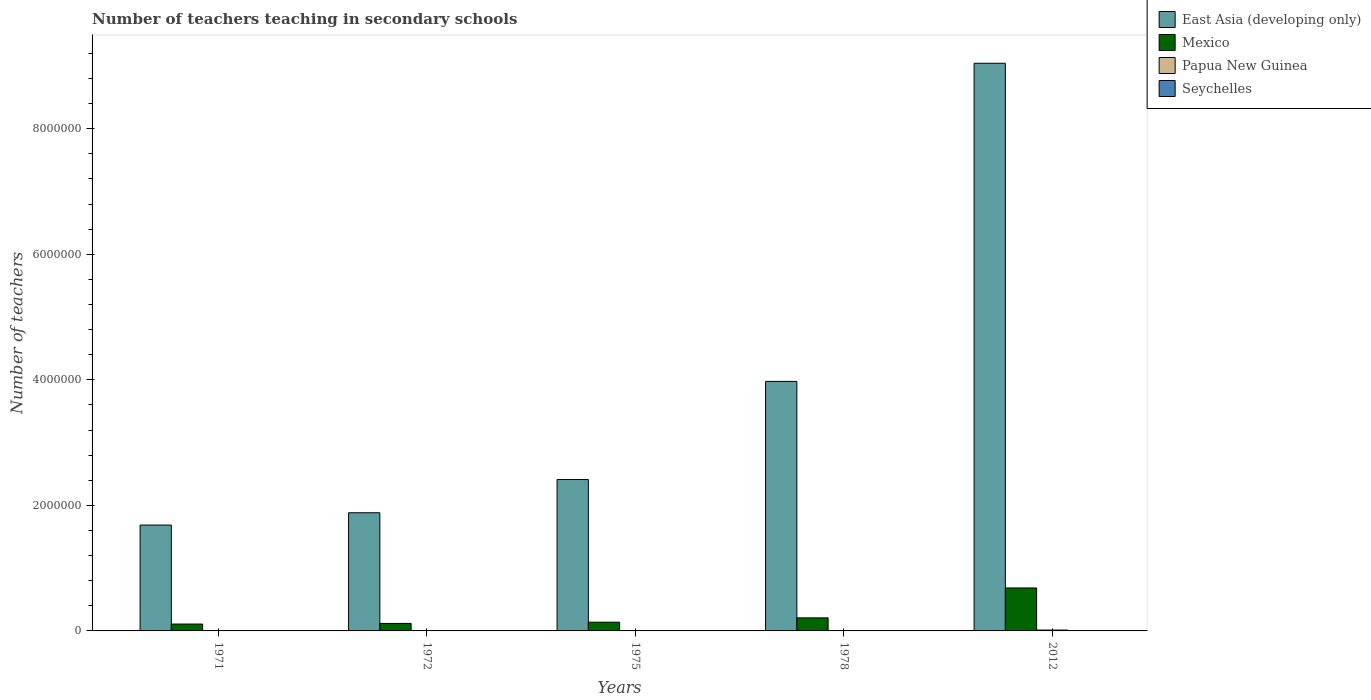How many different coloured bars are there?
Ensure brevity in your answer.  4. Are the number of bars on each tick of the X-axis equal?
Give a very brief answer. Yes. What is the label of the 1st group of bars from the left?
Offer a terse response. 1971. What is the number of teachers teaching in secondary schools in Mexico in 1975?
Your response must be concise. 1.39e+05. Across all years, what is the maximum number of teachers teaching in secondary schools in East Asia (developing only)?
Keep it short and to the point. 9.04e+06. Across all years, what is the minimum number of teachers teaching in secondary schools in Papua New Guinea?
Make the answer very short. 1358. What is the total number of teachers teaching in secondary schools in Seychelles in the graph?
Your response must be concise. 1324. What is the difference between the number of teachers teaching in secondary schools in Papua New Guinea in 1975 and the number of teachers teaching in secondary schools in East Asia (developing only) in 1978?
Provide a short and direct response. -3.97e+06. What is the average number of teachers teaching in secondary schools in Seychelles per year?
Ensure brevity in your answer.  264.8. In the year 1978, what is the difference between the number of teachers teaching in secondary schools in Papua New Guinea and number of teachers teaching in secondary schools in East Asia (developing only)?
Your answer should be very brief. -3.97e+06. In how many years, is the number of teachers teaching in secondary schools in Papua New Guinea greater than 400000?
Your response must be concise. 0. What is the ratio of the number of teachers teaching in secondary schools in Papua New Guinea in 1972 to that in 1975?
Offer a terse response. 0.83. What is the difference between the highest and the second highest number of teachers teaching in secondary schools in East Asia (developing only)?
Keep it short and to the point. 5.07e+06. What is the difference between the highest and the lowest number of teachers teaching in secondary schools in East Asia (developing only)?
Ensure brevity in your answer.  7.36e+06. In how many years, is the number of teachers teaching in secondary schools in Mexico greater than the average number of teachers teaching in secondary schools in Mexico taken over all years?
Your response must be concise. 1. Is the sum of the number of teachers teaching in secondary schools in Papua New Guinea in 1971 and 1972 greater than the maximum number of teachers teaching in secondary schools in Mexico across all years?
Keep it short and to the point. No. What does the 3rd bar from the left in 2012 represents?
Make the answer very short. Papua New Guinea. What does the 4th bar from the right in 1971 represents?
Your response must be concise. East Asia (developing only). Are all the bars in the graph horizontal?
Provide a short and direct response. No. How many years are there in the graph?
Your answer should be very brief. 5. Does the graph contain any zero values?
Make the answer very short. No. Where does the legend appear in the graph?
Keep it short and to the point. Top right. How many legend labels are there?
Your response must be concise. 4. What is the title of the graph?
Your response must be concise. Number of teachers teaching in secondary schools. Does "Belgium" appear as one of the legend labels in the graph?
Make the answer very short. No. What is the label or title of the Y-axis?
Offer a terse response. Number of teachers. What is the Number of teachers in East Asia (developing only) in 1971?
Your answer should be very brief. 1.69e+06. What is the Number of teachers of Mexico in 1971?
Keep it short and to the point. 1.09e+05. What is the Number of teachers of Papua New Guinea in 1971?
Provide a short and direct response. 1358. What is the Number of teachers of Seychelles in 1971?
Your response must be concise. 127. What is the Number of teachers of East Asia (developing only) in 1972?
Provide a short and direct response. 1.88e+06. What is the Number of teachers of Mexico in 1972?
Offer a very short reply. 1.20e+05. What is the Number of teachers in Papua New Guinea in 1972?
Offer a very short reply. 1681. What is the Number of teachers of Seychelles in 1972?
Make the answer very short. 140. What is the Number of teachers in East Asia (developing only) in 1975?
Offer a terse response. 2.41e+06. What is the Number of teachers of Mexico in 1975?
Provide a short and direct response. 1.39e+05. What is the Number of teachers of Papua New Guinea in 1975?
Offer a terse response. 2034. What is the Number of teachers of Seychelles in 1975?
Your answer should be compact. 177. What is the Number of teachers of East Asia (developing only) in 1978?
Offer a terse response. 3.97e+06. What is the Number of teachers in Mexico in 1978?
Offer a terse response. 2.08e+05. What is the Number of teachers of Papua New Guinea in 1978?
Your answer should be compact. 1954. What is the Number of teachers in Seychelles in 1978?
Give a very brief answer. 242. What is the Number of teachers of East Asia (developing only) in 2012?
Ensure brevity in your answer.  9.04e+06. What is the Number of teachers of Mexico in 2012?
Your answer should be very brief. 6.84e+05. What is the Number of teachers of Papua New Guinea in 2012?
Keep it short and to the point. 1.38e+04. What is the Number of teachers of Seychelles in 2012?
Offer a terse response. 638. Across all years, what is the maximum Number of teachers of East Asia (developing only)?
Offer a terse response. 9.04e+06. Across all years, what is the maximum Number of teachers in Mexico?
Your answer should be very brief. 6.84e+05. Across all years, what is the maximum Number of teachers in Papua New Guinea?
Provide a succinct answer. 1.38e+04. Across all years, what is the maximum Number of teachers in Seychelles?
Offer a terse response. 638. Across all years, what is the minimum Number of teachers of East Asia (developing only)?
Provide a succinct answer. 1.69e+06. Across all years, what is the minimum Number of teachers in Mexico?
Keep it short and to the point. 1.09e+05. Across all years, what is the minimum Number of teachers of Papua New Guinea?
Your response must be concise. 1358. Across all years, what is the minimum Number of teachers in Seychelles?
Offer a very short reply. 127. What is the total Number of teachers of East Asia (developing only) in the graph?
Make the answer very short. 1.90e+07. What is the total Number of teachers in Mexico in the graph?
Ensure brevity in your answer.  1.26e+06. What is the total Number of teachers in Papua New Guinea in the graph?
Ensure brevity in your answer.  2.08e+04. What is the total Number of teachers of Seychelles in the graph?
Offer a very short reply. 1324. What is the difference between the Number of teachers of East Asia (developing only) in 1971 and that in 1972?
Make the answer very short. -1.96e+05. What is the difference between the Number of teachers of Mexico in 1971 and that in 1972?
Offer a very short reply. -1.02e+04. What is the difference between the Number of teachers in Papua New Guinea in 1971 and that in 1972?
Your answer should be very brief. -323. What is the difference between the Number of teachers in East Asia (developing only) in 1971 and that in 1975?
Make the answer very short. -7.25e+05. What is the difference between the Number of teachers in Mexico in 1971 and that in 1975?
Provide a short and direct response. -2.95e+04. What is the difference between the Number of teachers in Papua New Guinea in 1971 and that in 1975?
Your answer should be very brief. -676. What is the difference between the Number of teachers of East Asia (developing only) in 1971 and that in 1978?
Keep it short and to the point. -2.29e+06. What is the difference between the Number of teachers of Mexico in 1971 and that in 1978?
Provide a short and direct response. -9.84e+04. What is the difference between the Number of teachers in Papua New Guinea in 1971 and that in 1978?
Give a very brief answer. -596. What is the difference between the Number of teachers of Seychelles in 1971 and that in 1978?
Offer a terse response. -115. What is the difference between the Number of teachers in East Asia (developing only) in 1971 and that in 2012?
Give a very brief answer. -7.36e+06. What is the difference between the Number of teachers in Mexico in 1971 and that in 2012?
Give a very brief answer. -5.75e+05. What is the difference between the Number of teachers in Papua New Guinea in 1971 and that in 2012?
Offer a very short reply. -1.24e+04. What is the difference between the Number of teachers of Seychelles in 1971 and that in 2012?
Keep it short and to the point. -511. What is the difference between the Number of teachers in East Asia (developing only) in 1972 and that in 1975?
Your answer should be very brief. -5.29e+05. What is the difference between the Number of teachers in Mexico in 1972 and that in 1975?
Your answer should be very brief. -1.93e+04. What is the difference between the Number of teachers in Papua New Guinea in 1972 and that in 1975?
Provide a succinct answer. -353. What is the difference between the Number of teachers of Seychelles in 1972 and that in 1975?
Keep it short and to the point. -37. What is the difference between the Number of teachers in East Asia (developing only) in 1972 and that in 1978?
Your answer should be compact. -2.09e+06. What is the difference between the Number of teachers of Mexico in 1972 and that in 1978?
Your answer should be very brief. -8.82e+04. What is the difference between the Number of teachers of Papua New Guinea in 1972 and that in 1978?
Your response must be concise. -273. What is the difference between the Number of teachers of Seychelles in 1972 and that in 1978?
Your response must be concise. -102. What is the difference between the Number of teachers in East Asia (developing only) in 1972 and that in 2012?
Your answer should be compact. -7.16e+06. What is the difference between the Number of teachers in Mexico in 1972 and that in 2012?
Provide a short and direct response. -5.65e+05. What is the difference between the Number of teachers in Papua New Guinea in 1972 and that in 2012?
Provide a short and direct response. -1.21e+04. What is the difference between the Number of teachers in Seychelles in 1972 and that in 2012?
Offer a terse response. -498. What is the difference between the Number of teachers of East Asia (developing only) in 1975 and that in 1978?
Provide a succinct answer. -1.56e+06. What is the difference between the Number of teachers in Mexico in 1975 and that in 1978?
Ensure brevity in your answer.  -6.89e+04. What is the difference between the Number of teachers of Seychelles in 1975 and that in 1978?
Your response must be concise. -65. What is the difference between the Number of teachers in East Asia (developing only) in 1975 and that in 2012?
Your answer should be compact. -6.63e+06. What is the difference between the Number of teachers in Mexico in 1975 and that in 2012?
Provide a succinct answer. -5.45e+05. What is the difference between the Number of teachers of Papua New Guinea in 1975 and that in 2012?
Offer a very short reply. -1.18e+04. What is the difference between the Number of teachers in Seychelles in 1975 and that in 2012?
Your answer should be compact. -461. What is the difference between the Number of teachers in East Asia (developing only) in 1978 and that in 2012?
Offer a terse response. -5.07e+06. What is the difference between the Number of teachers of Mexico in 1978 and that in 2012?
Offer a terse response. -4.76e+05. What is the difference between the Number of teachers in Papua New Guinea in 1978 and that in 2012?
Keep it short and to the point. -1.18e+04. What is the difference between the Number of teachers in Seychelles in 1978 and that in 2012?
Offer a terse response. -396. What is the difference between the Number of teachers in East Asia (developing only) in 1971 and the Number of teachers in Mexico in 1972?
Give a very brief answer. 1.57e+06. What is the difference between the Number of teachers in East Asia (developing only) in 1971 and the Number of teachers in Papua New Guinea in 1972?
Your answer should be compact. 1.68e+06. What is the difference between the Number of teachers of East Asia (developing only) in 1971 and the Number of teachers of Seychelles in 1972?
Offer a terse response. 1.69e+06. What is the difference between the Number of teachers of Mexico in 1971 and the Number of teachers of Papua New Guinea in 1972?
Your answer should be compact. 1.08e+05. What is the difference between the Number of teachers in Mexico in 1971 and the Number of teachers in Seychelles in 1972?
Make the answer very short. 1.09e+05. What is the difference between the Number of teachers in Papua New Guinea in 1971 and the Number of teachers in Seychelles in 1972?
Give a very brief answer. 1218. What is the difference between the Number of teachers of East Asia (developing only) in 1971 and the Number of teachers of Mexico in 1975?
Ensure brevity in your answer.  1.55e+06. What is the difference between the Number of teachers in East Asia (developing only) in 1971 and the Number of teachers in Papua New Guinea in 1975?
Give a very brief answer. 1.68e+06. What is the difference between the Number of teachers in East Asia (developing only) in 1971 and the Number of teachers in Seychelles in 1975?
Give a very brief answer. 1.69e+06. What is the difference between the Number of teachers of Mexico in 1971 and the Number of teachers of Papua New Guinea in 1975?
Offer a very short reply. 1.07e+05. What is the difference between the Number of teachers of Mexico in 1971 and the Number of teachers of Seychelles in 1975?
Provide a short and direct response. 1.09e+05. What is the difference between the Number of teachers of Papua New Guinea in 1971 and the Number of teachers of Seychelles in 1975?
Give a very brief answer. 1181. What is the difference between the Number of teachers in East Asia (developing only) in 1971 and the Number of teachers in Mexico in 1978?
Keep it short and to the point. 1.48e+06. What is the difference between the Number of teachers in East Asia (developing only) in 1971 and the Number of teachers in Papua New Guinea in 1978?
Make the answer very short. 1.68e+06. What is the difference between the Number of teachers in East Asia (developing only) in 1971 and the Number of teachers in Seychelles in 1978?
Ensure brevity in your answer.  1.69e+06. What is the difference between the Number of teachers of Mexico in 1971 and the Number of teachers of Papua New Guinea in 1978?
Provide a succinct answer. 1.08e+05. What is the difference between the Number of teachers of Mexico in 1971 and the Number of teachers of Seychelles in 1978?
Keep it short and to the point. 1.09e+05. What is the difference between the Number of teachers in Papua New Guinea in 1971 and the Number of teachers in Seychelles in 1978?
Offer a terse response. 1116. What is the difference between the Number of teachers in East Asia (developing only) in 1971 and the Number of teachers in Mexico in 2012?
Your answer should be very brief. 1.00e+06. What is the difference between the Number of teachers in East Asia (developing only) in 1971 and the Number of teachers in Papua New Guinea in 2012?
Offer a very short reply. 1.67e+06. What is the difference between the Number of teachers of East Asia (developing only) in 1971 and the Number of teachers of Seychelles in 2012?
Your response must be concise. 1.69e+06. What is the difference between the Number of teachers of Mexico in 1971 and the Number of teachers of Papua New Guinea in 2012?
Offer a very short reply. 9.57e+04. What is the difference between the Number of teachers in Mexico in 1971 and the Number of teachers in Seychelles in 2012?
Offer a terse response. 1.09e+05. What is the difference between the Number of teachers in Papua New Guinea in 1971 and the Number of teachers in Seychelles in 2012?
Give a very brief answer. 720. What is the difference between the Number of teachers in East Asia (developing only) in 1972 and the Number of teachers in Mexico in 1975?
Your answer should be compact. 1.74e+06. What is the difference between the Number of teachers in East Asia (developing only) in 1972 and the Number of teachers in Papua New Guinea in 1975?
Ensure brevity in your answer.  1.88e+06. What is the difference between the Number of teachers in East Asia (developing only) in 1972 and the Number of teachers in Seychelles in 1975?
Make the answer very short. 1.88e+06. What is the difference between the Number of teachers in Mexico in 1972 and the Number of teachers in Papua New Guinea in 1975?
Keep it short and to the point. 1.18e+05. What is the difference between the Number of teachers of Mexico in 1972 and the Number of teachers of Seychelles in 1975?
Your response must be concise. 1.20e+05. What is the difference between the Number of teachers in Papua New Guinea in 1972 and the Number of teachers in Seychelles in 1975?
Provide a short and direct response. 1504. What is the difference between the Number of teachers of East Asia (developing only) in 1972 and the Number of teachers of Mexico in 1978?
Offer a very short reply. 1.67e+06. What is the difference between the Number of teachers of East Asia (developing only) in 1972 and the Number of teachers of Papua New Guinea in 1978?
Provide a short and direct response. 1.88e+06. What is the difference between the Number of teachers in East Asia (developing only) in 1972 and the Number of teachers in Seychelles in 1978?
Keep it short and to the point. 1.88e+06. What is the difference between the Number of teachers of Mexico in 1972 and the Number of teachers of Papua New Guinea in 1978?
Your answer should be compact. 1.18e+05. What is the difference between the Number of teachers of Mexico in 1972 and the Number of teachers of Seychelles in 1978?
Give a very brief answer. 1.19e+05. What is the difference between the Number of teachers in Papua New Guinea in 1972 and the Number of teachers in Seychelles in 1978?
Ensure brevity in your answer.  1439. What is the difference between the Number of teachers of East Asia (developing only) in 1972 and the Number of teachers of Mexico in 2012?
Your answer should be very brief. 1.20e+06. What is the difference between the Number of teachers of East Asia (developing only) in 1972 and the Number of teachers of Papua New Guinea in 2012?
Your answer should be compact. 1.87e+06. What is the difference between the Number of teachers in East Asia (developing only) in 1972 and the Number of teachers in Seychelles in 2012?
Provide a short and direct response. 1.88e+06. What is the difference between the Number of teachers of Mexico in 1972 and the Number of teachers of Papua New Guinea in 2012?
Your answer should be very brief. 1.06e+05. What is the difference between the Number of teachers of Mexico in 1972 and the Number of teachers of Seychelles in 2012?
Give a very brief answer. 1.19e+05. What is the difference between the Number of teachers of Papua New Guinea in 1972 and the Number of teachers of Seychelles in 2012?
Keep it short and to the point. 1043. What is the difference between the Number of teachers of East Asia (developing only) in 1975 and the Number of teachers of Mexico in 1978?
Your answer should be compact. 2.20e+06. What is the difference between the Number of teachers of East Asia (developing only) in 1975 and the Number of teachers of Papua New Guinea in 1978?
Offer a very short reply. 2.41e+06. What is the difference between the Number of teachers of East Asia (developing only) in 1975 and the Number of teachers of Seychelles in 1978?
Keep it short and to the point. 2.41e+06. What is the difference between the Number of teachers of Mexico in 1975 and the Number of teachers of Papua New Guinea in 1978?
Make the answer very short. 1.37e+05. What is the difference between the Number of teachers of Mexico in 1975 and the Number of teachers of Seychelles in 1978?
Keep it short and to the point. 1.39e+05. What is the difference between the Number of teachers of Papua New Guinea in 1975 and the Number of teachers of Seychelles in 1978?
Give a very brief answer. 1792. What is the difference between the Number of teachers of East Asia (developing only) in 1975 and the Number of teachers of Mexico in 2012?
Provide a succinct answer. 1.73e+06. What is the difference between the Number of teachers in East Asia (developing only) in 1975 and the Number of teachers in Papua New Guinea in 2012?
Your response must be concise. 2.40e+06. What is the difference between the Number of teachers of East Asia (developing only) in 1975 and the Number of teachers of Seychelles in 2012?
Provide a succinct answer. 2.41e+06. What is the difference between the Number of teachers in Mexico in 1975 and the Number of teachers in Papua New Guinea in 2012?
Ensure brevity in your answer.  1.25e+05. What is the difference between the Number of teachers in Mexico in 1975 and the Number of teachers in Seychelles in 2012?
Make the answer very short. 1.38e+05. What is the difference between the Number of teachers in Papua New Guinea in 1975 and the Number of teachers in Seychelles in 2012?
Make the answer very short. 1396. What is the difference between the Number of teachers in East Asia (developing only) in 1978 and the Number of teachers in Mexico in 2012?
Your answer should be compact. 3.29e+06. What is the difference between the Number of teachers of East Asia (developing only) in 1978 and the Number of teachers of Papua New Guinea in 2012?
Your answer should be very brief. 3.96e+06. What is the difference between the Number of teachers of East Asia (developing only) in 1978 and the Number of teachers of Seychelles in 2012?
Your response must be concise. 3.97e+06. What is the difference between the Number of teachers of Mexico in 1978 and the Number of teachers of Papua New Guinea in 2012?
Offer a very short reply. 1.94e+05. What is the difference between the Number of teachers in Mexico in 1978 and the Number of teachers in Seychelles in 2012?
Provide a short and direct response. 2.07e+05. What is the difference between the Number of teachers in Papua New Guinea in 1978 and the Number of teachers in Seychelles in 2012?
Keep it short and to the point. 1316. What is the average Number of teachers in East Asia (developing only) per year?
Make the answer very short. 3.80e+06. What is the average Number of teachers in Mexico per year?
Give a very brief answer. 2.52e+05. What is the average Number of teachers of Papua New Guinea per year?
Your answer should be very brief. 4166.2. What is the average Number of teachers of Seychelles per year?
Offer a very short reply. 264.8. In the year 1971, what is the difference between the Number of teachers in East Asia (developing only) and Number of teachers in Mexico?
Make the answer very short. 1.58e+06. In the year 1971, what is the difference between the Number of teachers of East Asia (developing only) and Number of teachers of Papua New Guinea?
Your answer should be compact. 1.68e+06. In the year 1971, what is the difference between the Number of teachers in East Asia (developing only) and Number of teachers in Seychelles?
Give a very brief answer. 1.69e+06. In the year 1971, what is the difference between the Number of teachers of Mexico and Number of teachers of Papua New Guinea?
Your answer should be very brief. 1.08e+05. In the year 1971, what is the difference between the Number of teachers in Mexico and Number of teachers in Seychelles?
Ensure brevity in your answer.  1.09e+05. In the year 1971, what is the difference between the Number of teachers in Papua New Guinea and Number of teachers in Seychelles?
Offer a very short reply. 1231. In the year 1972, what is the difference between the Number of teachers in East Asia (developing only) and Number of teachers in Mexico?
Ensure brevity in your answer.  1.76e+06. In the year 1972, what is the difference between the Number of teachers of East Asia (developing only) and Number of teachers of Papua New Guinea?
Make the answer very short. 1.88e+06. In the year 1972, what is the difference between the Number of teachers in East Asia (developing only) and Number of teachers in Seychelles?
Your response must be concise. 1.88e+06. In the year 1972, what is the difference between the Number of teachers of Mexico and Number of teachers of Papua New Guinea?
Your answer should be compact. 1.18e+05. In the year 1972, what is the difference between the Number of teachers in Mexico and Number of teachers in Seychelles?
Your answer should be compact. 1.20e+05. In the year 1972, what is the difference between the Number of teachers of Papua New Guinea and Number of teachers of Seychelles?
Give a very brief answer. 1541. In the year 1975, what is the difference between the Number of teachers in East Asia (developing only) and Number of teachers in Mexico?
Your answer should be very brief. 2.27e+06. In the year 1975, what is the difference between the Number of teachers of East Asia (developing only) and Number of teachers of Papua New Guinea?
Your answer should be very brief. 2.41e+06. In the year 1975, what is the difference between the Number of teachers of East Asia (developing only) and Number of teachers of Seychelles?
Give a very brief answer. 2.41e+06. In the year 1975, what is the difference between the Number of teachers in Mexico and Number of teachers in Papua New Guinea?
Offer a terse response. 1.37e+05. In the year 1975, what is the difference between the Number of teachers in Mexico and Number of teachers in Seychelles?
Keep it short and to the point. 1.39e+05. In the year 1975, what is the difference between the Number of teachers in Papua New Guinea and Number of teachers in Seychelles?
Give a very brief answer. 1857. In the year 1978, what is the difference between the Number of teachers in East Asia (developing only) and Number of teachers in Mexico?
Give a very brief answer. 3.77e+06. In the year 1978, what is the difference between the Number of teachers in East Asia (developing only) and Number of teachers in Papua New Guinea?
Your answer should be compact. 3.97e+06. In the year 1978, what is the difference between the Number of teachers in East Asia (developing only) and Number of teachers in Seychelles?
Provide a short and direct response. 3.97e+06. In the year 1978, what is the difference between the Number of teachers in Mexico and Number of teachers in Papua New Guinea?
Give a very brief answer. 2.06e+05. In the year 1978, what is the difference between the Number of teachers in Mexico and Number of teachers in Seychelles?
Provide a short and direct response. 2.08e+05. In the year 1978, what is the difference between the Number of teachers in Papua New Guinea and Number of teachers in Seychelles?
Offer a very short reply. 1712. In the year 2012, what is the difference between the Number of teachers in East Asia (developing only) and Number of teachers in Mexico?
Your response must be concise. 8.36e+06. In the year 2012, what is the difference between the Number of teachers of East Asia (developing only) and Number of teachers of Papua New Guinea?
Ensure brevity in your answer.  9.03e+06. In the year 2012, what is the difference between the Number of teachers in East Asia (developing only) and Number of teachers in Seychelles?
Your response must be concise. 9.04e+06. In the year 2012, what is the difference between the Number of teachers in Mexico and Number of teachers in Papua New Guinea?
Provide a succinct answer. 6.70e+05. In the year 2012, what is the difference between the Number of teachers in Mexico and Number of teachers in Seychelles?
Make the answer very short. 6.84e+05. In the year 2012, what is the difference between the Number of teachers in Papua New Guinea and Number of teachers in Seychelles?
Your response must be concise. 1.32e+04. What is the ratio of the Number of teachers of East Asia (developing only) in 1971 to that in 1972?
Your answer should be very brief. 0.9. What is the ratio of the Number of teachers in Mexico in 1971 to that in 1972?
Offer a very short reply. 0.91. What is the ratio of the Number of teachers of Papua New Guinea in 1971 to that in 1972?
Offer a terse response. 0.81. What is the ratio of the Number of teachers in Seychelles in 1971 to that in 1972?
Offer a very short reply. 0.91. What is the ratio of the Number of teachers in East Asia (developing only) in 1971 to that in 1975?
Offer a terse response. 0.7. What is the ratio of the Number of teachers in Mexico in 1971 to that in 1975?
Provide a succinct answer. 0.79. What is the ratio of the Number of teachers of Papua New Guinea in 1971 to that in 1975?
Keep it short and to the point. 0.67. What is the ratio of the Number of teachers of Seychelles in 1971 to that in 1975?
Give a very brief answer. 0.72. What is the ratio of the Number of teachers of East Asia (developing only) in 1971 to that in 1978?
Offer a terse response. 0.42. What is the ratio of the Number of teachers of Mexico in 1971 to that in 1978?
Provide a short and direct response. 0.53. What is the ratio of the Number of teachers of Papua New Guinea in 1971 to that in 1978?
Your answer should be very brief. 0.69. What is the ratio of the Number of teachers of Seychelles in 1971 to that in 1978?
Provide a succinct answer. 0.52. What is the ratio of the Number of teachers in East Asia (developing only) in 1971 to that in 2012?
Offer a very short reply. 0.19. What is the ratio of the Number of teachers in Mexico in 1971 to that in 2012?
Give a very brief answer. 0.16. What is the ratio of the Number of teachers in Papua New Guinea in 1971 to that in 2012?
Make the answer very short. 0.1. What is the ratio of the Number of teachers of Seychelles in 1971 to that in 2012?
Provide a short and direct response. 0.2. What is the ratio of the Number of teachers in East Asia (developing only) in 1972 to that in 1975?
Your answer should be compact. 0.78. What is the ratio of the Number of teachers of Mexico in 1972 to that in 1975?
Your answer should be very brief. 0.86. What is the ratio of the Number of teachers in Papua New Guinea in 1972 to that in 1975?
Provide a short and direct response. 0.83. What is the ratio of the Number of teachers in Seychelles in 1972 to that in 1975?
Ensure brevity in your answer.  0.79. What is the ratio of the Number of teachers in East Asia (developing only) in 1972 to that in 1978?
Give a very brief answer. 0.47. What is the ratio of the Number of teachers in Mexico in 1972 to that in 1978?
Provide a short and direct response. 0.58. What is the ratio of the Number of teachers in Papua New Guinea in 1972 to that in 1978?
Give a very brief answer. 0.86. What is the ratio of the Number of teachers in Seychelles in 1972 to that in 1978?
Your answer should be very brief. 0.58. What is the ratio of the Number of teachers of East Asia (developing only) in 1972 to that in 2012?
Provide a succinct answer. 0.21. What is the ratio of the Number of teachers in Mexico in 1972 to that in 2012?
Make the answer very short. 0.17. What is the ratio of the Number of teachers in Papua New Guinea in 1972 to that in 2012?
Ensure brevity in your answer.  0.12. What is the ratio of the Number of teachers in Seychelles in 1972 to that in 2012?
Offer a very short reply. 0.22. What is the ratio of the Number of teachers of East Asia (developing only) in 1975 to that in 1978?
Give a very brief answer. 0.61. What is the ratio of the Number of teachers of Mexico in 1975 to that in 1978?
Your answer should be very brief. 0.67. What is the ratio of the Number of teachers of Papua New Guinea in 1975 to that in 1978?
Give a very brief answer. 1.04. What is the ratio of the Number of teachers in Seychelles in 1975 to that in 1978?
Provide a succinct answer. 0.73. What is the ratio of the Number of teachers of East Asia (developing only) in 1975 to that in 2012?
Offer a very short reply. 0.27. What is the ratio of the Number of teachers of Mexico in 1975 to that in 2012?
Offer a very short reply. 0.2. What is the ratio of the Number of teachers of Papua New Guinea in 1975 to that in 2012?
Keep it short and to the point. 0.15. What is the ratio of the Number of teachers of Seychelles in 1975 to that in 2012?
Ensure brevity in your answer.  0.28. What is the ratio of the Number of teachers of East Asia (developing only) in 1978 to that in 2012?
Offer a terse response. 0.44. What is the ratio of the Number of teachers in Mexico in 1978 to that in 2012?
Offer a terse response. 0.3. What is the ratio of the Number of teachers in Papua New Guinea in 1978 to that in 2012?
Your response must be concise. 0.14. What is the ratio of the Number of teachers of Seychelles in 1978 to that in 2012?
Your answer should be compact. 0.38. What is the difference between the highest and the second highest Number of teachers in East Asia (developing only)?
Make the answer very short. 5.07e+06. What is the difference between the highest and the second highest Number of teachers in Mexico?
Offer a very short reply. 4.76e+05. What is the difference between the highest and the second highest Number of teachers in Papua New Guinea?
Your answer should be compact. 1.18e+04. What is the difference between the highest and the second highest Number of teachers in Seychelles?
Ensure brevity in your answer.  396. What is the difference between the highest and the lowest Number of teachers in East Asia (developing only)?
Make the answer very short. 7.36e+06. What is the difference between the highest and the lowest Number of teachers of Mexico?
Keep it short and to the point. 5.75e+05. What is the difference between the highest and the lowest Number of teachers of Papua New Guinea?
Keep it short and to the point. 1.24e+04. What is the difference between the highest and the lowest Number of teachers of Seychelles?
Offer a very short reply. 511. 